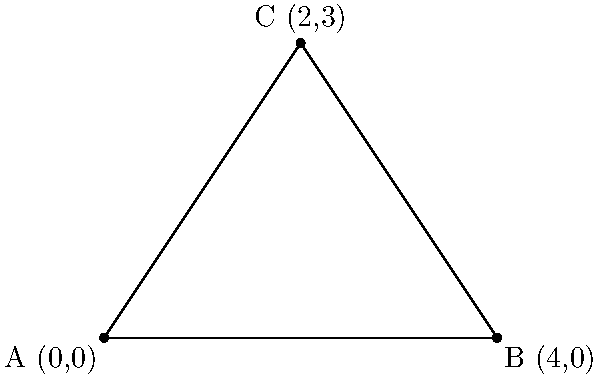Hãy xác định tọa độ của đỉnh C trong tam giác ABC được vẽ trên hệ trục tọa độ. Để xác định tọa độ của đỉnh C, chúng ta cần quan sát vị trí của nó trên hệ trục tọa độ:

1. Trục hoành (trục x):
   - Đỉnh C nằm giữa A(0,0) và B(4,0)
   - Khoảng cách từ A đến C bằng một nửa khoảng cách từ A đến B
   - Vì vậy, tọa độ x của C là: $(0 + 4) \div 2 = 2$

2. Trục tung (trục y):
   - Đỉnh C nằm 3 đơn vị phía trên trục x
   - Do đó, tọa độ y của C là 3

Kết hợp tọa độ x và y, chúng ta có tọa độ của đỉnh C là (2,3).
Answer: (2,3) 